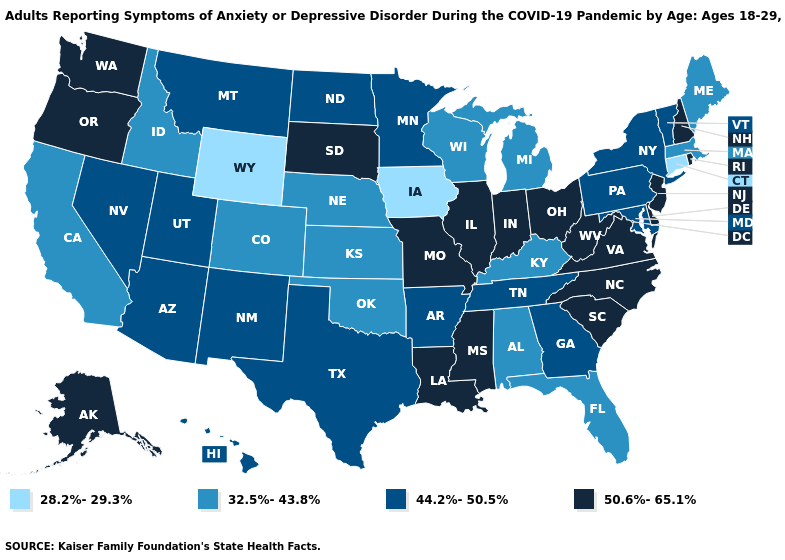Name the states that have a value in the range 28.2%-29.3%?
Concise answer only. Connecticut, Iowa, Wyoming. Name the states that have a value in the range 32.5%-43.8%?
Keep it brief. Alabama, California, Colorado, Florida, Idaho, Kansas, Kentucky, Maine, Massachusetts, Michigan, Nebraska, Oklahoma, Wisconsin. Does Wyoming have the lowest value in the West?
Give a very brief answer. Yes. What is the lowest value in the Northeast?
Answer briefly. 28.2%-29.3%. What is the lowest value in the USA?
Give a very brief answer. 28.2%-29.3%. Among the states that border Alabama , which have the highest value?
Keep it brief. Mississippi. Which states hav the highest value in the South?
Concise answer only. Delaware, Louisiana, Mississippi, North Carolina, South Carolina, Virginia, West Virginia. What is the value of North Dakota?
Be succinct. 44.2%-50.5%. What is the value of Mississippi?
Be succinct. 50.6%-65.1%. What is the value of Wisconsin?
Give a very brief answer. 32.5%-43.8%. What is the highest value in the USA?
Be succinct. 50.6%-65.1%. Does Indiana have the highest value in the MidWest?
Write a very short answer. Yes. Does Montana have the highest value in the West?
Concise answer only. No. Does Alabama have a higher value than Utah?
Quick response, please. No. Among the states that border Arkansas , which have the highest value?
Give a very brief answer. Louisiana, Mississippi, Missouri. 